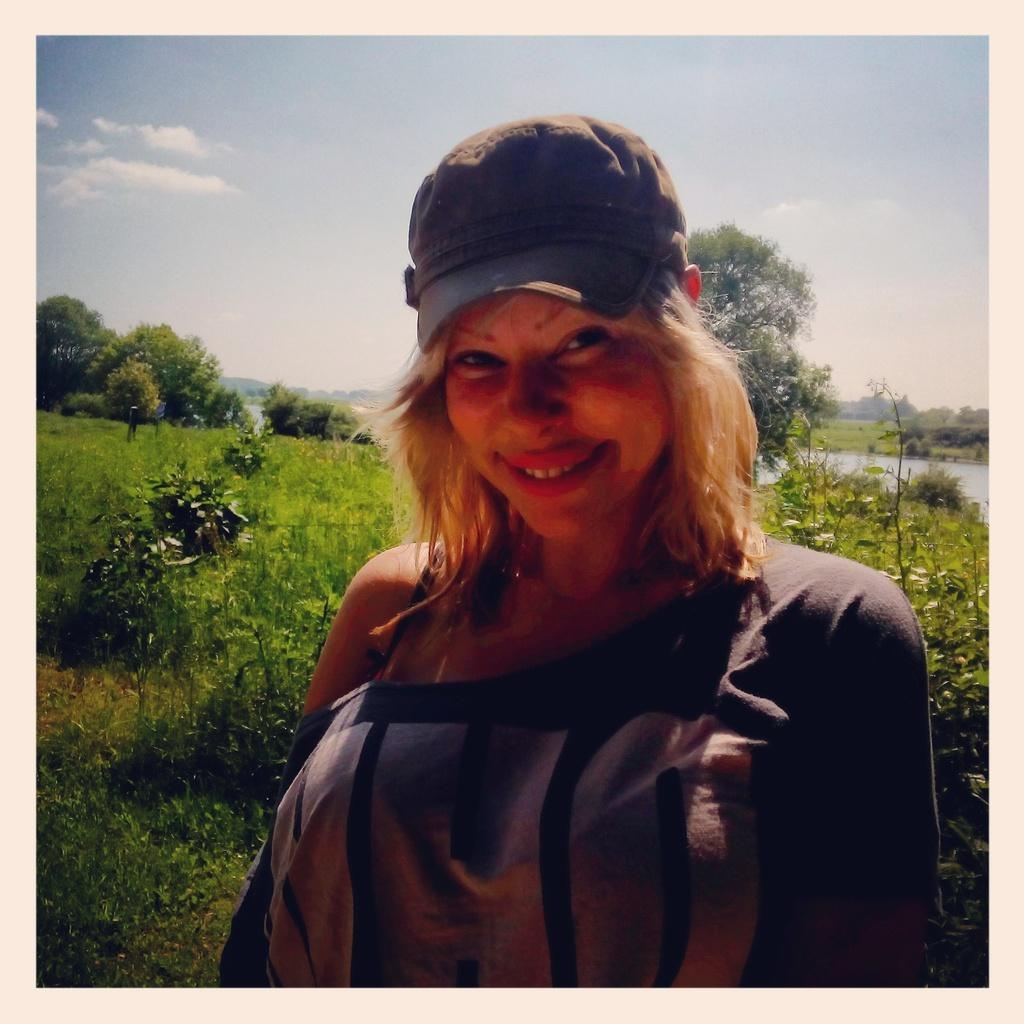Who is present in the image? There is a woman in the image. What type of vegetation can be seen in the image? Plants, grass, and trees are visible in the image. What body of water is present in the image? There is a lake in the image. How many pizzas are being served on the lamp in the image? There is no lamp or pizzas present in the image. 